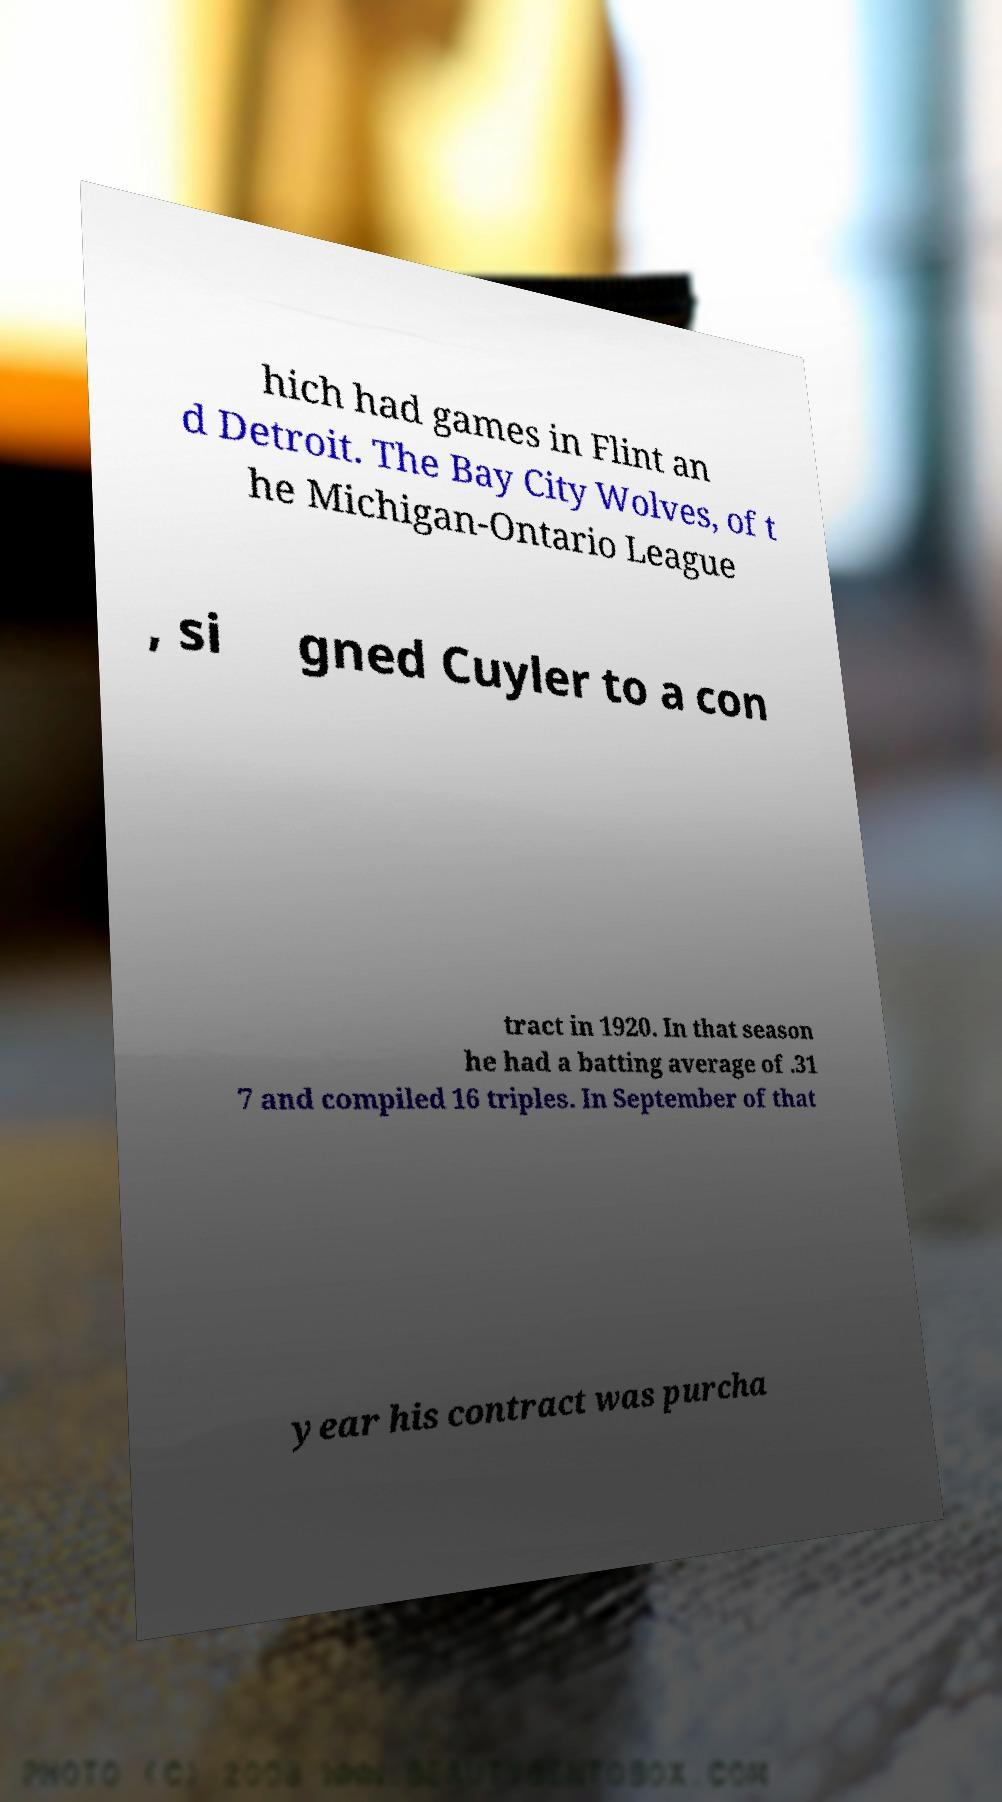Could you assist in decoding the text presented in this image and type it out clearly? hich had games in Flint an d Detroit. The Bay City Wolves, of t he Michigan-Ontario League , si gned Cuyler to a con tract in 1920. In that season he had a batting average of .31 7 and compiled 16 triples. In September of that year his contract was purcha 